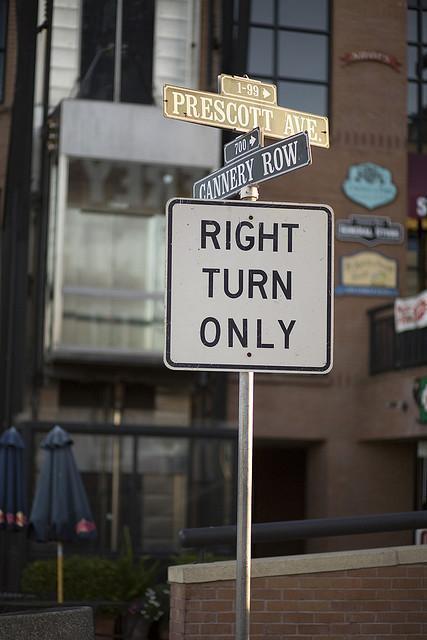How many umbrellas are in the picture?
Give a very brief answer. 2. 